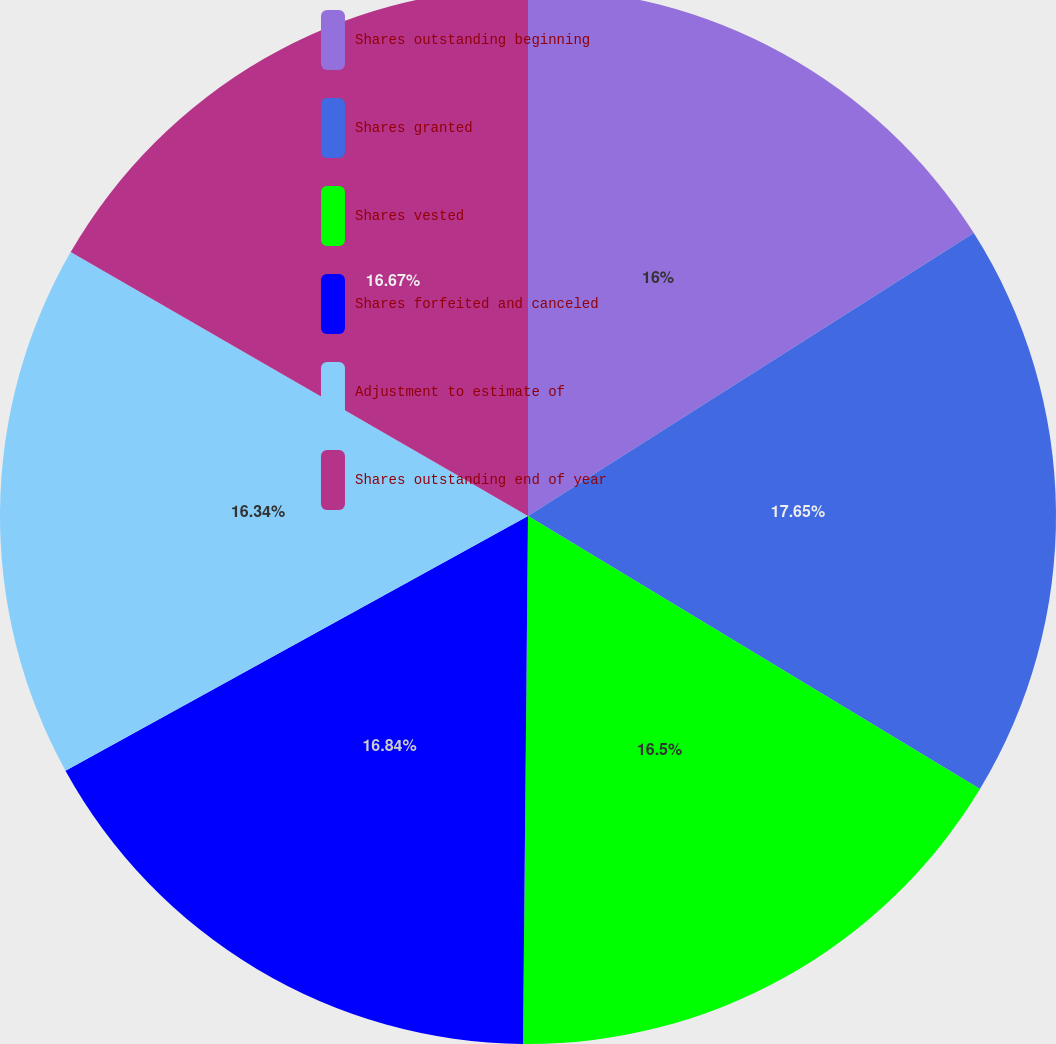<chart> <loc_0><loc_0><loc_500><loc_500><pie_chart><fcel>Shares outstanding beginning<fcel>Shares granted<fcel>Shares vested<fcel>Shares forfeited and canceled<fcel>Adjustment to estimate of<fcel>Shares outstanding end of year<nl><fcel>16.0%<fcel>17.65%<fcel>16.5%<fcel>16.84%<fcel>16.34%<fcel>16.67%<nl></chart> 